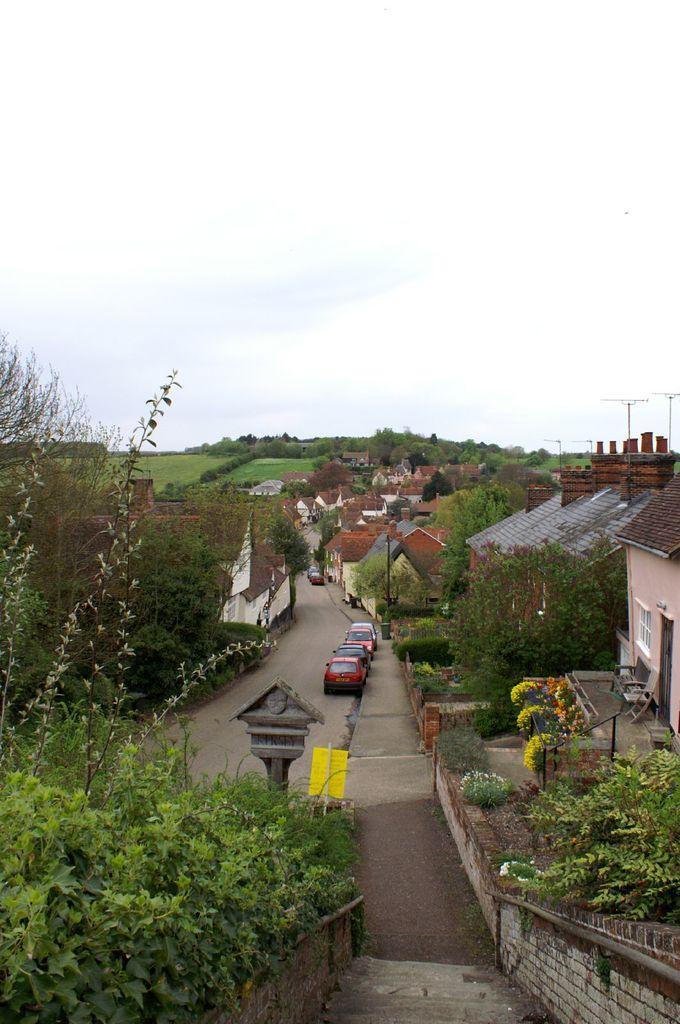Can you describe this image briefly? In this image there are trees and houses on the left and right corner. There are steps, vehicles. There are houses, vehicles, trees in the background. And there is sky at the top. 